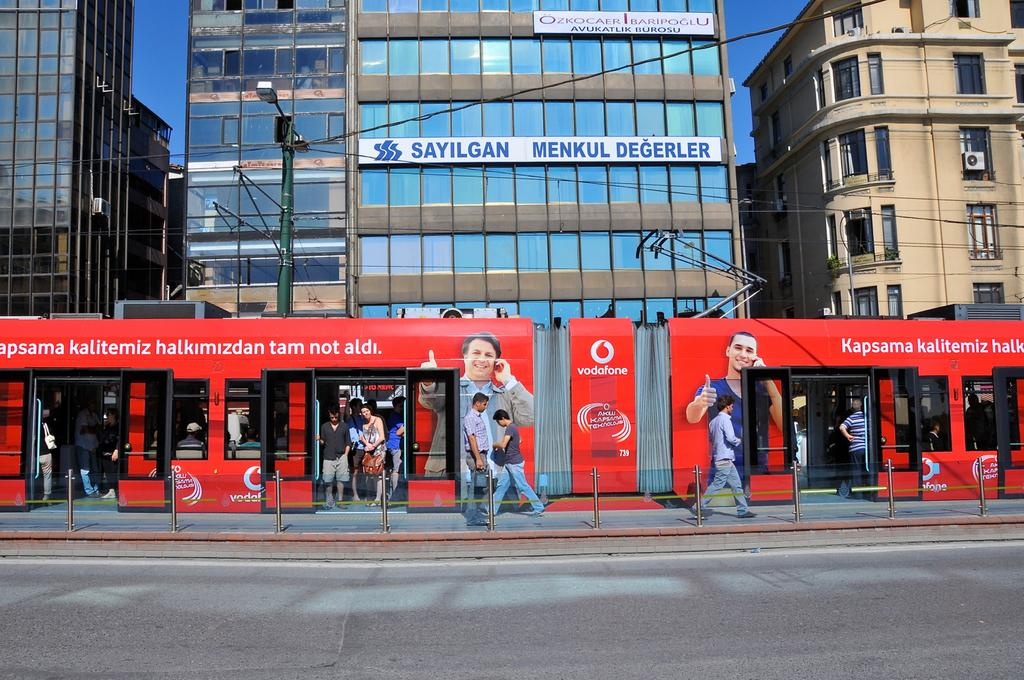What is the main feature of the image? There is a road in the image. What are the people in the image doing? There are people walking on the path, and some people are in a train. What type of lighting is present in the image? There is a street light in the image. What can be seen in the background of the image? There are buildings in the background of the image. How many kittens are playing with an orange in the image? There are no kittens or oranges present in the image. Are there any girls visible in the image? The provided facts do not mention any girls in the image. 